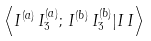<formula> <loc_0><loc_0><loc_500><loc_500>\left < I ^ { ( a ) } \, I ^ { ( a ) } _ { 3 } ; \, I ^ { ( b ) } \, I ^ { ( b ) } _ { 3 } | I \, I \right ></formula> 